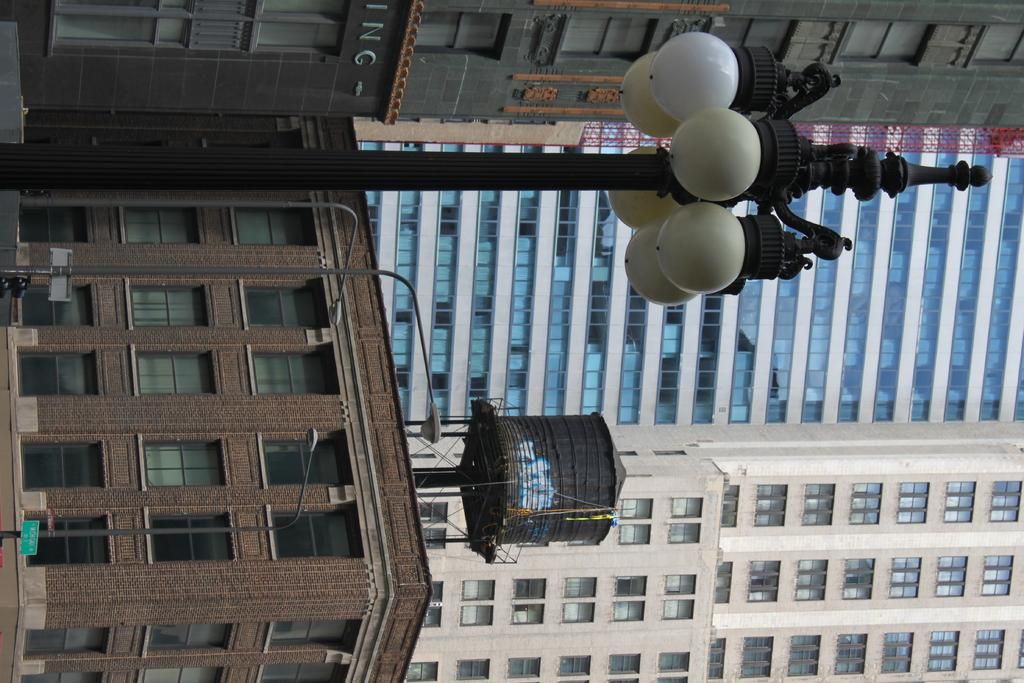What type of structures can be seen in the image? There are buildings in the image. What else is present in the image besides buildings? There are poles, lights, and windows in the image. Can you describe the water tank in the image? There is a water tank at the top of a building in the image. What type of appliance is being used to plant seeds in the garden? There is no garden or appliance present in the image; it features buildings, poles, lights, windows, and a water tank. What type of pest can be seen crawling on the windows in the image? There are no pests visible on the windows in the image. 